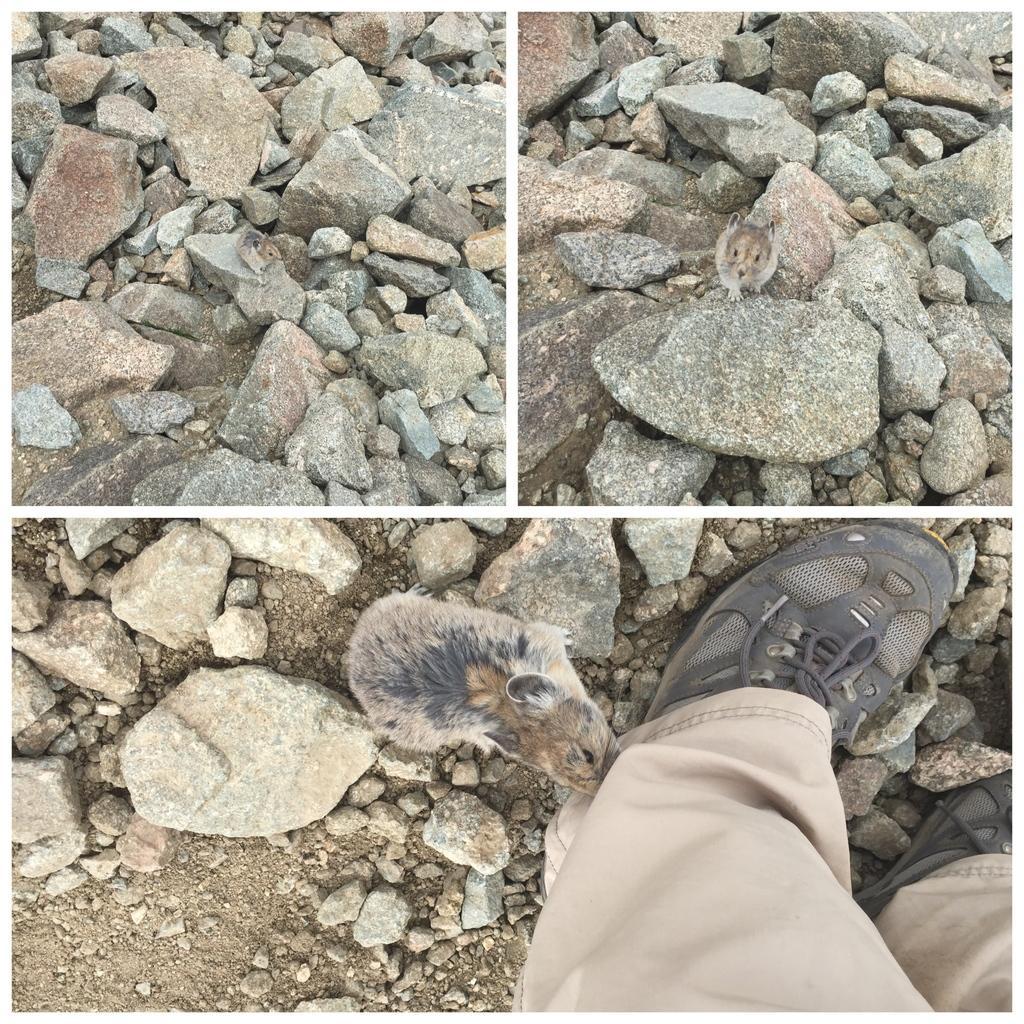How would you summarize this image in a sentence or two? This is collage picture,in this pictures we can see stones,rats and persons legs. 